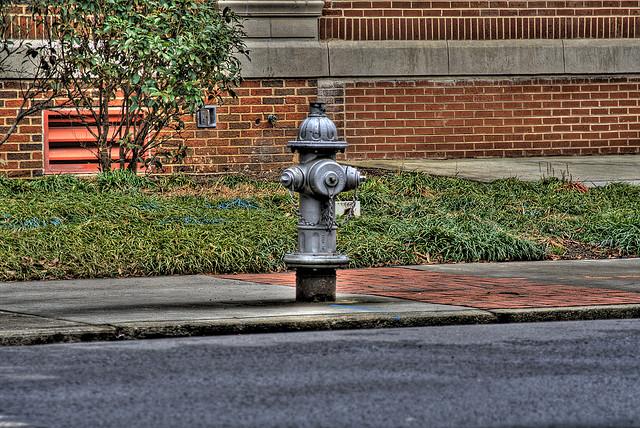How many people on the sidewalk?
Give a very brief answer. 0. Are the hydrant colors the same as the colors of the Italian flag?
Keep it brief. No. Is this outdoors?
Quick response, please. Yes. Is this city clean?
Short answer required. Yes. What dog is the hydrant depicting?
Concise answer only. None. 